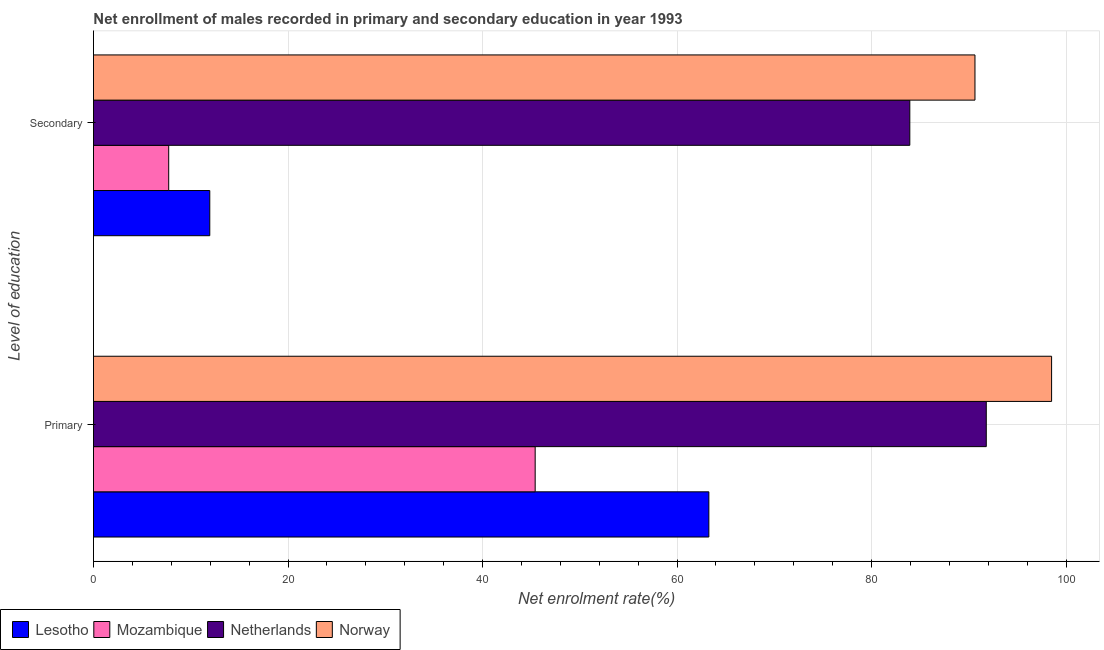How many different coloured bars are there?
Make the answer very short. 4. How many groups of bars are there?
Your answer should be very brief. 2. How many bars are there on the 1st tick from the top?
Your answer should be very brief. 4. What is the label of the 1st group of bars from the top?
Make the answer very short. Secondary. What is the enrollment rate in primary education in Lesotho?
Offer a very short reply. 63.27. Across all countries, what is the maximum enrollment rate in primary education?
Keep it short and to the point. 98.51. Across all countries, what is the minimum enrollment rate in primary education?
Keep it short and to the point. 45.41. In which country was the enrollment rate in secondary education maximum?
Your response must be concise. Norway. In which country was the enrollment rate in secondary education minimum?
Ensure brevity in your answer.  Mozambique. What is the total enrollment rate in secondary education in the graph?
Make the answer very short. 194.25. What is the difference between the enrollment rate in secondary education in Mozambique and that in Netherlands?
Make the answer very short. -76.19. What is the difference between the enrollment rate in secondary education in Netherlands and the enrollment rate in primary education in Lesotho?
Keep it short and to the point. 20.66. What is the average enrollment rate in primary education per country?
Your response must be concise. 74.74. What is the difference between the enrollment rate in primary education and enrollment rate in secondary education in Mozambique?
Ensure brevity in your answer.  37.68. In how many countries, is the enrollment rate in secondary education greater than 52 %?
Provide a succinct answer. 2. What is the ratio of the enrollment rate in primary education in Norway to that in Lesotho?
Keep it short and to the point. 1.56. What does the 1st bar from the bottom in Secondary represents?
Ensure brevity in your answer.  Lesotho. Are all the bars in the graph horizontal?
Your response must be concise. Yes. How many countries are there in the graph?
Your answer should be compact. 4. Are the values on the major ticks of X-axis written in scientific E-notation?
Provide a succinct answer. No. Does the graph contain any zero values?
Keep it short and to the point. No. Does the graph contain grids?
Your response must be concise. Yes. How are the legend labels stacked?
Give a very brief answer. Horizontal. What is the title of the graph?
Make the answer very short. Net enrollment of males recorded in primary and secondary education in year 1993. Does "Ethiopia" appear as one of the legend labels in the graph?
Give a very brief answer. No. What is the label or title of the X-axis?
Provide a succinct answer. Net enrolment rate(%). What is the label or title of the Y-axis?
Offer a very short reply. Level of education. What is the Net enrolment rate(%) in Lesotho in Primary?
Provide a short and direct response. 63.27. What is the Net enrolment rate(%) of Mozambique in Primary?
Make the answer very short. 45.41. What is the Net enrolment rate(%) in Netherlands in Primary?
Offer a very short reply. 91.79. What is the Net enrolment rate(%) of Norway in Primary?
Offer a terse response. 98.51. What is the Net enrolment rate(%) of Lesotho in Secondary?
Offer a very short reply. 11.96. What is the Net enrolment rate(%) in Mozambique in Secondary?
Provide a short and direct response. 7.73. What is the Net enrolment rate(%) of Netherlands in Secondary?
Ensure brevity in your answer.  83.93. What is the Net enrolment rate(%) in Norway in Secondary?
Ensure brevity in your answer.  90.63. Across all Level of education, what is the maximum Net enrolment rate(%) of Lesotho?
Provide a short and direct response. 63.27. Across all Level of education, what is the maximum Net enrolment rate(%) in Mozambique?
Offer a very short reply. 45.41. Across all Level of education, what is the maximum Net enrolment rate(%) in Netherlands?
Ensure brevity in your answer.  91.79. Across all Level of education, what is the maximum Net enrolment rate(%) in Norway?
Make the answer very short. 98.51. Across all Level of education, what is the minimum Net enrolment rate(%) of Lesotho?
Give a very brief answer. 11.96. Across all Level of education, what is the minimum Net enrolment rate(%) in Mozambique?
Your answer should be very brief. 7.73. Across all Level of education, what is the minimum Net enrolment rate(%) of Netherlands?
Your answer should be very brief. 83.93. Across all Level of education, what is the minimum Net enrolment rate(%) in Norway?
Your response must be concise. 90.63. What is the total Net enrolment rate(%) in Lesotho in the graph?
Offer a very short reply. 75.23. What is the total Net enrolment rate(%) in Mozambique in the graph?
Make the answer very short. 53.15. What is the total Net enrolment rate(%) of Netherlands in the graph?
Make the answer very short. 175.72. What is the total Net enrolment rate(%) of Norway in the graph?
Give a very brief answer. 189.13. What is the difference between the Net enrolment rate(%) of Lesotho in Primary and that in Secondary?
Your answer should be compact. 51.31. What is the difference between the Net enrolment rate(%) in Mozambique in Primary and that in Secondary?
Keep it short and to the point. 37.68. What is the difference between the Net enrolment rate(%) of Netherlands in Primary and that in Secondary?
Give a very brief answer. 7.86. What is the difference between the Net enrolment rate(%) of Norway in Primary and that in Secondary?
Provide a succinct answer. 7.88. What is the difference between the Net enrolment rate(%) of Lesotho in Primary and the Net enrolment rate(%) of Mozambique in Secondary?
Make the answer very short. 55.53. What is the difference between the Net enrolment rate(%) of Lesotho in Primary and the Net enrolment rate(%) of Netherlands in Secondary?
Make the answer very short. -20.66. What is the difference between the Net enrolment rate(%) of Lesotho in Primary and the Net enrolment rate(%) of Norway in Secondary?
Keep it short and to the point. -27.36. What is the difference between the Net enrolment rate(%) of Mozambique in Primary and the Net enrolment rate(%) of Netherlands in Secondary?
Your answer should be compact. -38.52. What is the difference between the Net enrolment rate(%) of Mozambique in Primary and the Net enrolment rate(%) of Norway in Secondary?
Give a very brief answer. -45.22. What is the difference between the Net enrolment rate(%) of Netherlands in Primary and the Net enrolment rate(%) of Norway in Secondary?
Your response must be concise. 1.16. What is the average Net enrolment rate(%) in Lesotho per Level of education?
Provide a succinct answer. 37.61. What is the average Net enrolment rate(%) of Mozambique per Level of education?
Your answer should be very brief. 26.57. What is the average Net enrolment rate(%) in Netherlands per Level of education?
Make the answer very short. 87.86. What is the average Net enrolment rate(%) in Norway per Level of education?
Give a very brief answer. 94.57. What is the difference between the Net enrolment rate(%) of Lesotho and Net enrolment rate(%) of Mozambique in Primary?
Your answer should be very brief. 17.86. What is the difference between the Net enrolment rate(%) of Lesotho and Net enrolment rate(%) of Netherlands in Primary?
Provide a short and direct response. -28.52. What is the difference between the Net enrolment rate(%) of Lesotho and Net enrolment rate(%) of Norway in Primary?
Make the answer very short. -35.24. What is the difference between the Net enrolment rate(%) in Mozambique and Net enrolment rate(%) in Netherlands in Primary?
Offer a terse response. -46.38. What is the difference between the Net enrolment rate(%) in Mozambique and Net enrolment rate(%) in Norway in Primary?
Offer a very short reply. -53.09. What is the difference between the Net enrolment rate(%) of Netherlands and Net enrolment rate(%) of Norway in Primary?
Ensure brevity in your answer.  -6.71. What is the difference between the Net enrolment rate(%) in Lesotho and Net enrolment rate(%) in Mozambique in Secondary?
Your response must be concise. 4.22. What is the difference between the Net enrolment rate(%) in Lesotho and Net enrolment rate(%) in Netherlands in Secondary?
Provide a succinct answer. -71.97. What is the difference between the Net enrolment rate(%) of Lesotho and Net enrolment rate(%) of Norway in Secondary?
Your answer should be very brief. -78.67. What is the difference between the Net enrolment rate(%) in Mozambique and Net enrolment rate(%) in Netherlands in Secondary?
Keep it short and to the point. -76.19. What is the difference between the Net enrolment rate(%) in Mozambique and Net enrolment rate(%) in Norway in Secondary?
Ensure brevity in your answer.  -82.89. What is the difference between the Net enrolment rate(%) of Netherlands and Net enrolment rate(%) of Norway in Secondary?
Your answer should be compact. -6.7. What is the ratio of the Net enrolment rate(%) of Lesotho in Primary to that in Secondary?
Provide a short and direct response. 5.29. What is the ratio of the Net enrolment rate(%) of Mozambique in Primary to that in Secondary?
Provide a short and direct response. 5.87. What is the ratio of the Net enrolment rate(%) of Netherlands in Primary to that in Secondary?
Offer a very short reply. 1.09. What is the ratio of the Net enrolment rate(%) in Norway in Primary to that in Secondary?
Provide a short and direct response. 1.09. What is the difference between the highest and the second highest Net enrolment rate(%) in Lesotho?
Your response must be concise. 51.31. What is the difference between the highest and the second highest Net enrolment rate(%) of Mozambique?
Offer a terse response. 37.68. What is the difference between the highest and the second highest Net enrolment rate(%) of Netherlands?
Make the answer very short. 7.86. What is the difference between the highest and the second highest Net enrolment rate(%) in Norway?
Provide a succinct answer. 7.88. What is the difference between the highest and the lowest Net enrolment rate(%) in Lesotho?
Keep it short and to the point. 51.31. What is the difference between the highest and the lowest Net enrolment rate(%) of Mozambique?
Your answer should be very brief. 37.68. What is the difference between the highest and the lowest Net enrolment rate(%) in Netherlands?
Make the answer very short. 7.86. What is the difference between the highest and the lowest Net enrolment rate(%) in Norway?
Ensure brevity in your answer.  7.88. 